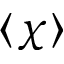Convert formula to latex. <formula><loc_0><loc_0><loc_500><loc_500>\langle \chi \rangle</formula> 